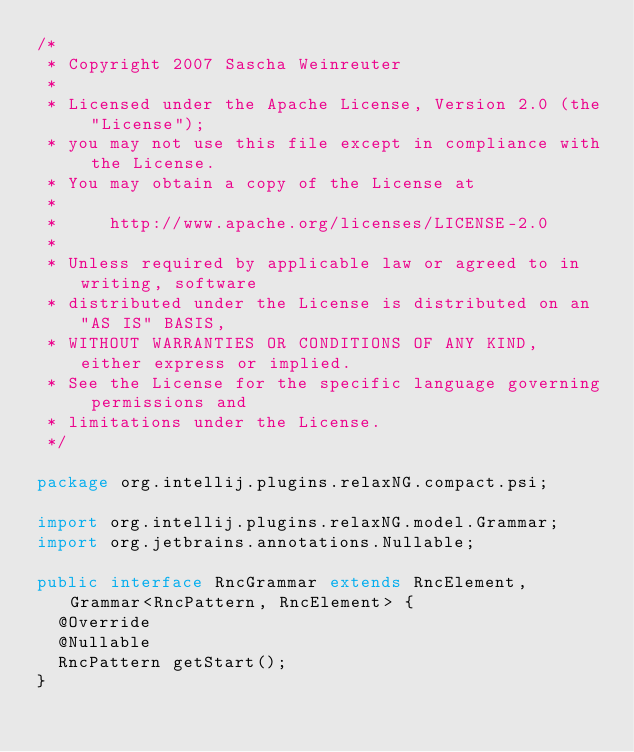<code> <loc_0><loc_0><loc_500><loc_500><_Java_>/*
 * Copyright 2007 Sascha Weinreuter
 *
 * Licensed under the Apache License, Version 2.0 (the "License");
 * you may not use this file except in compliance with the License.
 * You may obtain a copy of the License at
 *
 *     http://www.apache.org/licenses/LICENSE-2.0
 *
 * Unless required by applicable law or agreed to in writing, software
 * distributed under the License is distributed on an "AS IS" BASIS,
 * WITHOUT WARRANTIES OR CONDITIONS OF ANY KIND, either express or implied.
 * See the License for the specific language governing permissions and
 * limitations under the License.
 */

package org.intellij.plugins.relaxNG.compact.psi;

import org.intellij.plugins.relaxNG.model.Grammar;
import org.jetbrains.annotations.Nullable;

public interface RncGrammar extends RncElement, Grammar<RncPattern, RncElement> {
  @Override
  @Nullable
  RncPattern getStart();
}
</code> 